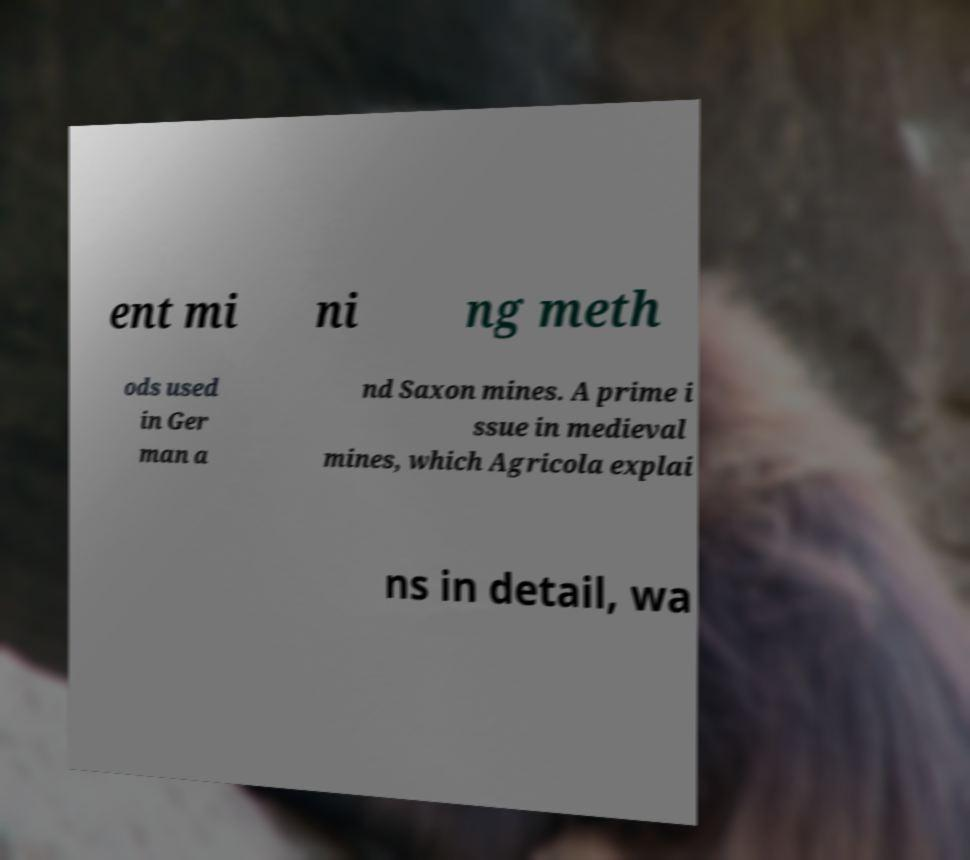What messages or text are displayed in this image? I need them in a readable, typed format. ent mi ni ng meth ods used in Ger man a nd Saxon mines. A prime i ssue in medieval mines, which Agricola explai ns in detail, wa 